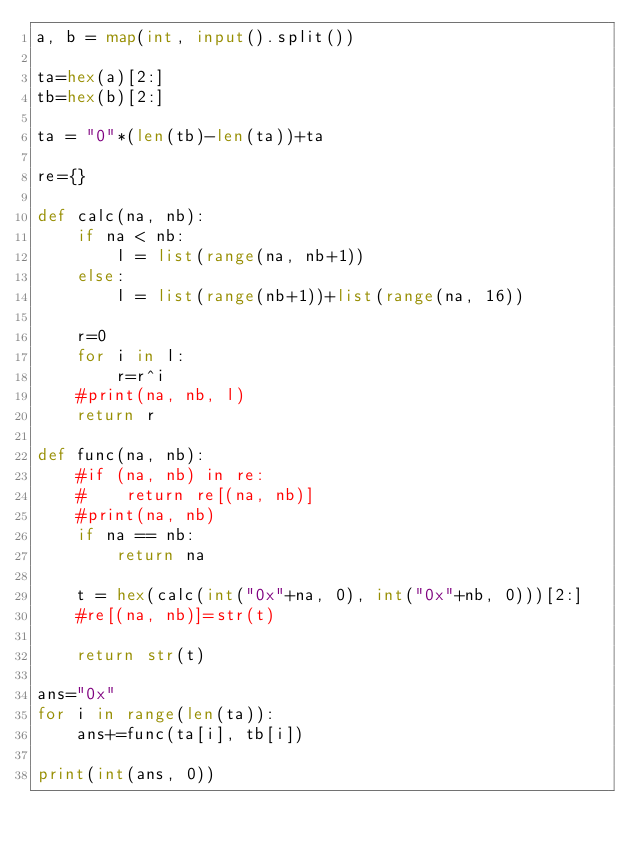<code> <loc_0><loc_0><loc_500><loc_500><_Python_>a, b = map(int, input().split())

ta=hex(a)[2:]
tb=hex(b)[2:]

ta = "0"*(len(tb)-len(ta))+ta

re={}

def calc(na, nb):
    if na < nb:
        l = list(range(na, nb+1))
    else:
        l = list(range(nb+1))+list(range(na, 16))

    r=0
    for i in l:
        r=r^i
    #print(na, nb, l)
    return r

def func(na, nb):
    #if (na, nb) in re:
    #    return re[(na, nb)]
    #print(na, nb)
    if na == nb:
        return na

    t = hex(calc(int("0x"+na, 0), int("0x"+nb, 0)))[2:]
    #re[(na, nb)]=str(t)

    return str(t)

ans="0x"
for i in range(len(ta)):
    ans+=func(ta[i], tb[i])

print(int(ans, 0))

</code> 